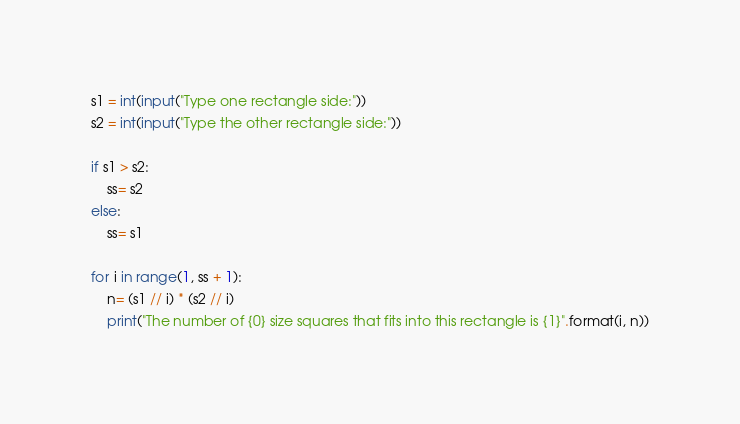<code> <loc_0><loc_0><loc_500><loc_500><_Python_>s1 = int(input("Type one rectangle side:"))
s2 = int(input("Type the other rectangle side:"))

if s1 > s2:
	ss= s2
else:
	ss= s1

for i in range(1, ss + 1):
	n= (s1 // i) * (s2 // i)
	print("The number of {0} size squares that fits into this rectangle is {1}".format(i, n))
</code> 